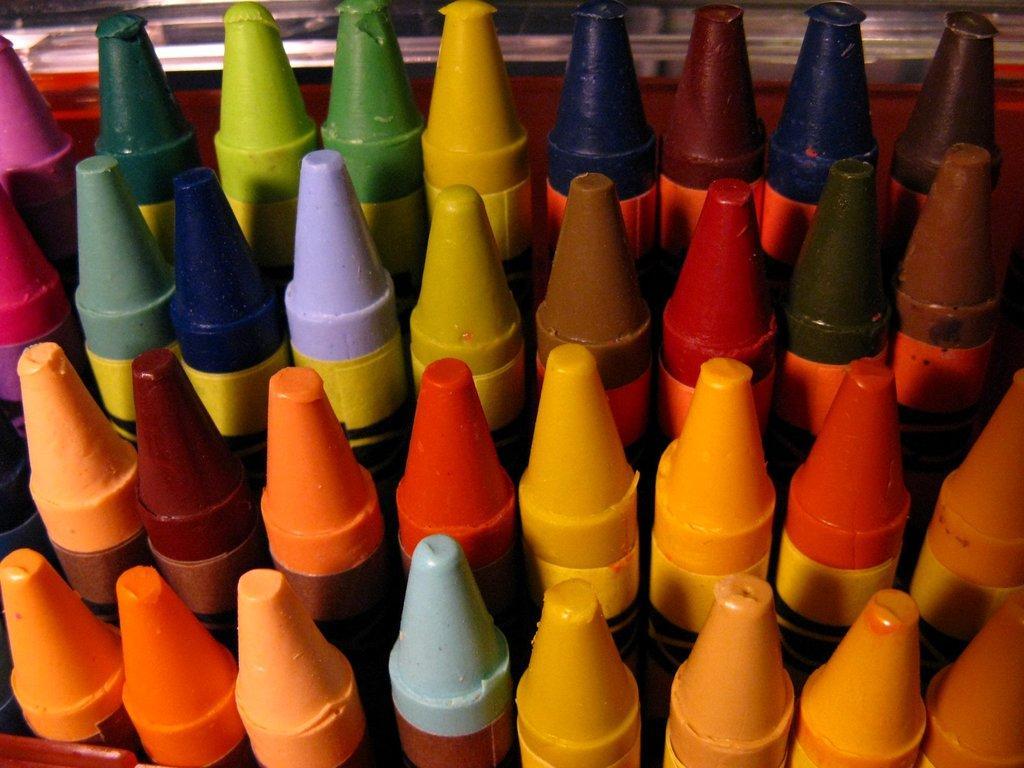Please provide a concise description of this image. In this picture we can see crayons. 